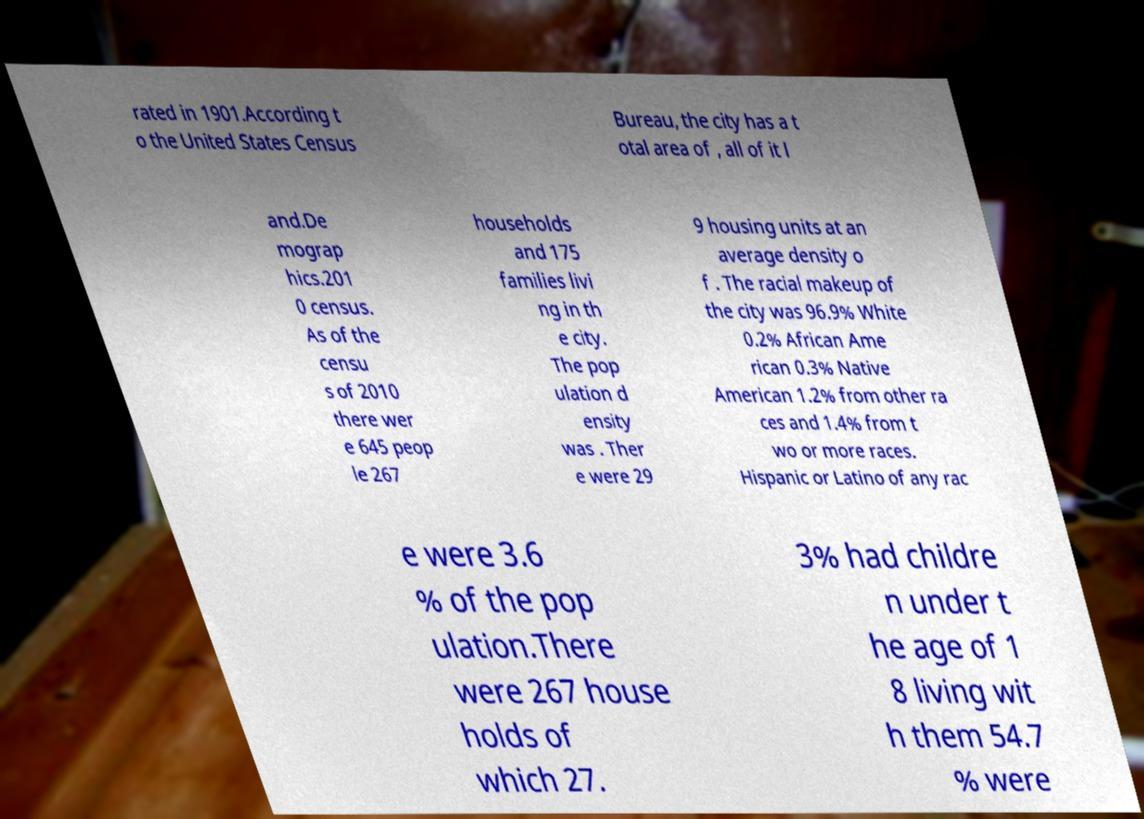Please identify and transcribe the text found in this image. rated in 1901.According t o the United States Census Bureau, the city has a t otal area of , all of it l and.De mograp hics.201 0 census. As of the censu s of 2010 there wer e 645 peop le 267 households and 175 families livi ng in th e city. The pop ulation d ensity was . Ther e were 29 9 housing units at an average density o f . The racial makeup of the city was 96.9% White 0.2% African Ame rican 0.3% Native American 1.2% from other ra ces and 1.4% from t wo or more races. Hispanic or Latino of any rac e were 3.6 % of the pop ulation.There were 267 house holds of which 27. 3% had childre n under t he age of 1 8 living wit h them 54.7 % were 